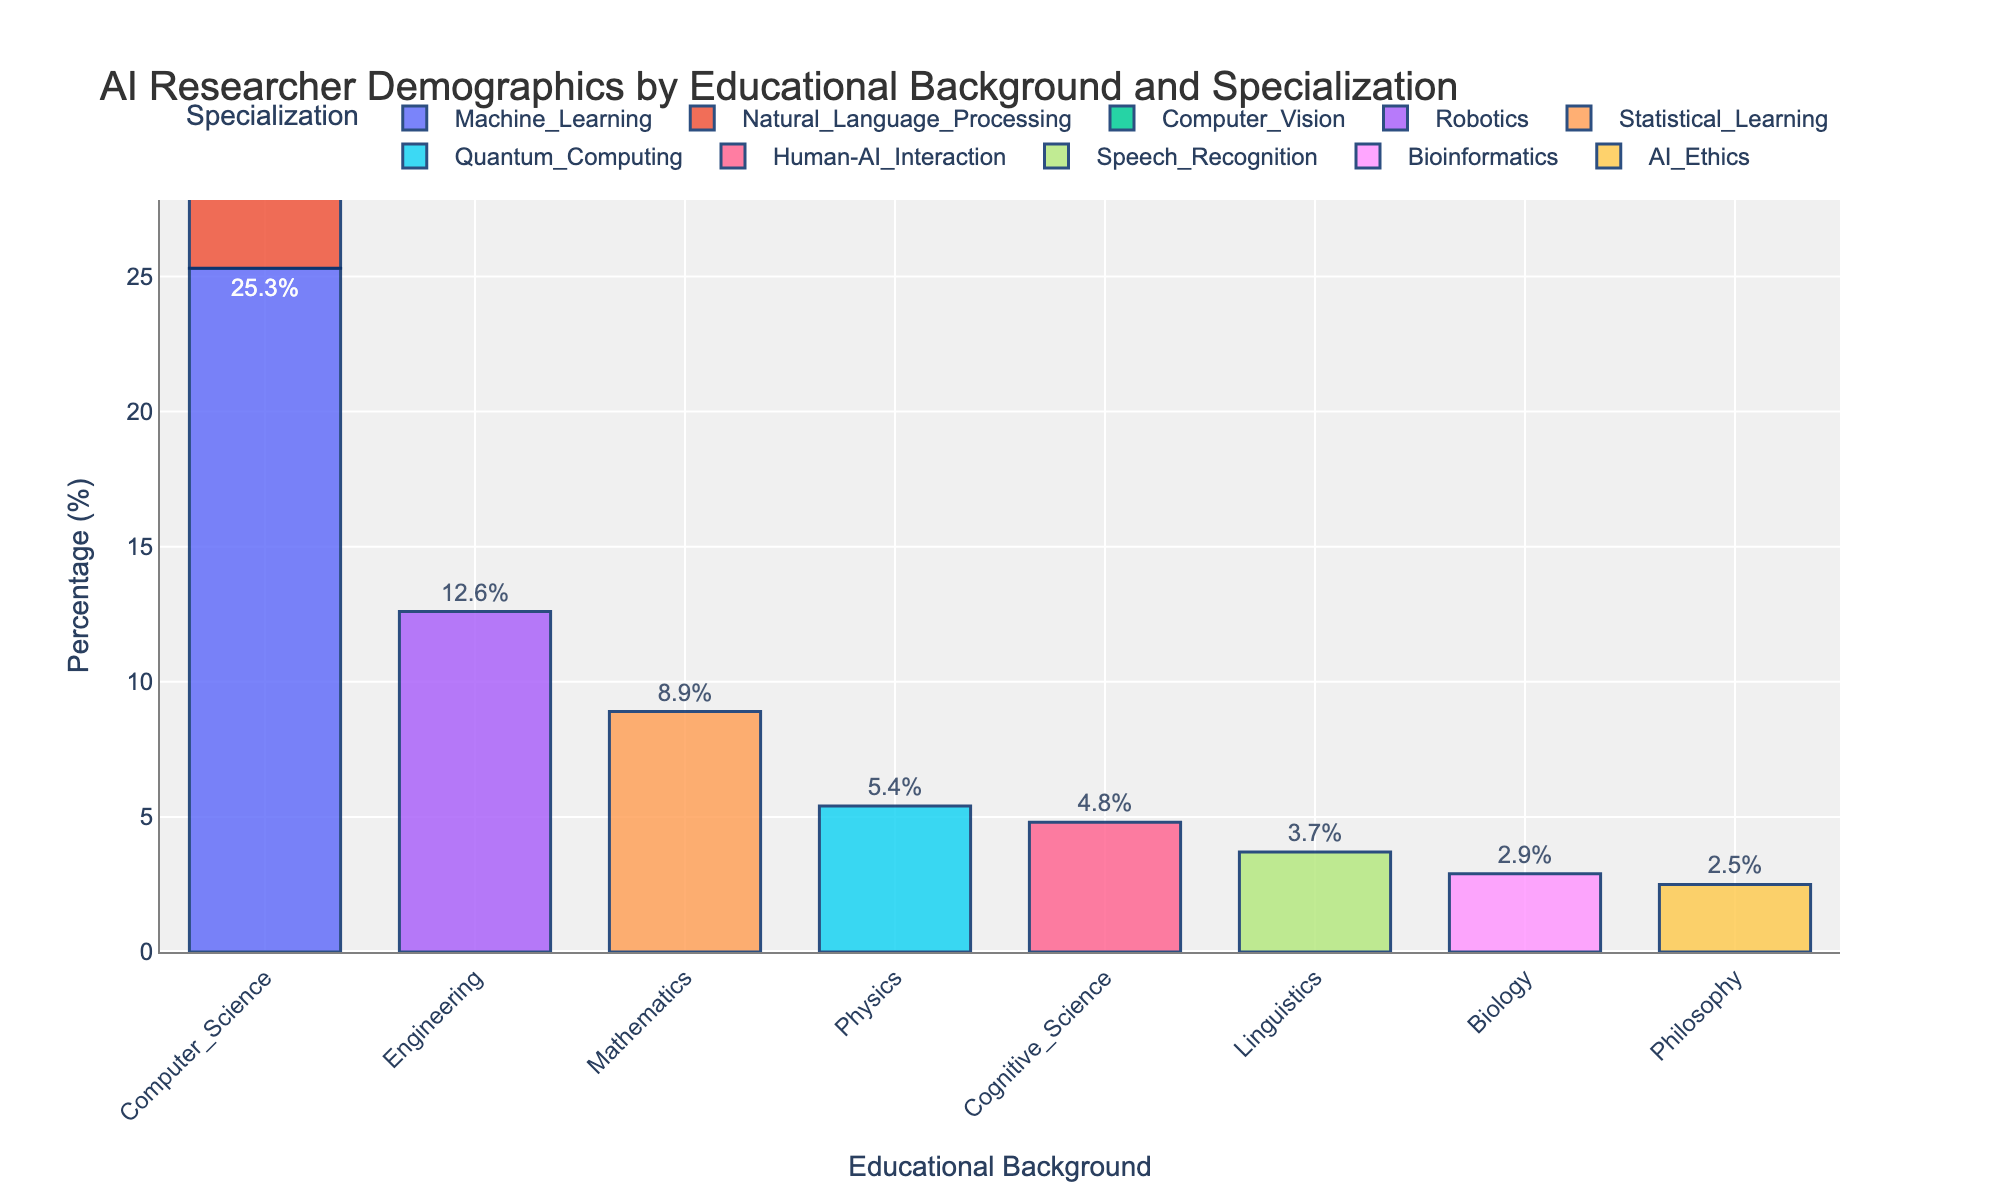What educational background has the highest percentage of AI researchers specializing in Machine Learning? By looking at the height of the bars and the labels on the x-axis, we can find which educational background has the highest percentage in the Machine Learning category. The bar labeled "Computer Science" is the tallest among the bars representing Machine Learning.
Answer: Computer Science Compare the percentage of AI researchers with a Computer Science background specializing in Natural Language Processing to those specializing in Computer Vision. Which specialization has a higher percentage? By comparing the heights of the bars labeled "Computer Science" and colored for Natural Language Processing and Computer Vision, we find that Natural Language Processing (18.7%) is higher than Computer Vision (15.2%).
Answer: Natural Language Processing Find the total percentage of AI researchers with backgrounds in Physics, Cognitive Science, Linguistics, Biology, and Philosophy combined. Sum the percentages for these backgrounds: Physics (5.4%) + Cognitive Science (4.8%) + Linguistics (3.7%) + Biology (2.9%) + Philosophy (2.5%). The total is 19.3%.
Answer: 19.3% Which specialization under the Computer Science background has the lowest percentage of AI researchers? By observing the bars under the "Computer Science" category, we can see that Computer Vision, with 15.2%, is the lowest percentage among Machine Learning, Natural Language Processing, and Computer Vision.
Answer: Computer Vision What is the difference in percentage between AI researchers specializing in Robotics (Engineering background) and those specializing in Bioinformatics (Biology background)? Subtract the percentage of Bioinformatics (2.9%) from the percentage of Robotics (12.6%); the difference is 9.7%.
Answer: 9.7% How does the percentage of AI researchers specializing in AI Ethics (Philosophy background) compare to those specializing in Human-AI Interaction (Cognitive Science background)? By comparing the bars under Philosophy and Cognitive Science backgrounds, the percentage for AI Ethics (2.5%) is less than that for Human-AI Interaction (4.8%).
Answer: Human-AI Interaction What is the combined percentage of AI researchers specializing in Machine Learning and Natural Language Processing within the Computer Science background? Add the percentages of Machine Learning (25.3%) and Natural Language Processing (18.7%); the total is 44.0%.
Answer: 44.0% Which specialization has the highest percentage among the listed ones, and what is the percentage? By looking at all the bars, the highest bar represents Machine Learning under the Computer Science background with 25.3%.
Answer: Machine Learning, 25.3% Calculate the average percentage of AI researchers across all educational backgrounds and specializations. Sum all the percentages given and divide by the number of total data points. (25.3 + 18.7 + 15.2 + 12.6 + 8.9 + 5.4 + 4.8 + 3.7 + 2.9 + 2.5) / 10 = 100 / 10 = 10%.
Answer: 10% Visualize the most and least common specialization within the Computer Science background by comparing the heights of the bars. What are the specializations, and what are their respective percentages? The tallest bar under Computer Science is Machine Learning (25.3%), and the shortest is Computer Vision (15.2%).
Answer: Machine Learning: 25.3%, Computer Vision: 15.2% 